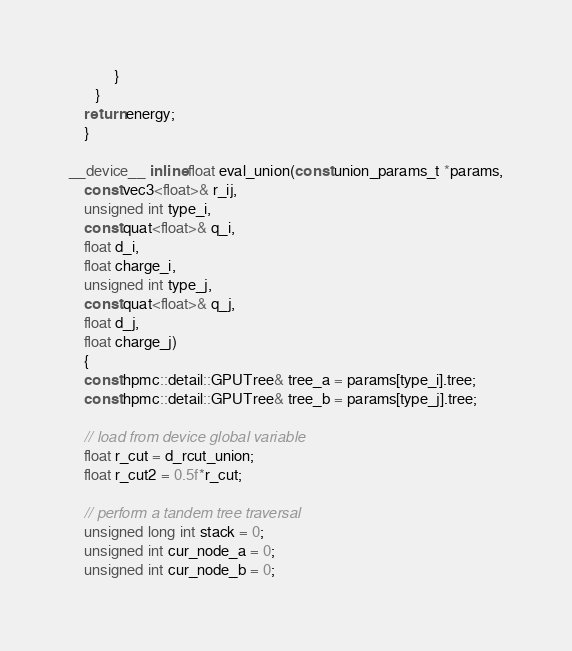Convert code to text. <code><loc_0><loc_0><loc_500><loc_500><_Cuda_>            }
       }
    return energy;
    }

__device__ inline float eval_union(const union_params_t *params,
    const vec3<float>& r_ij,
    unsigned int type_i,
    const quat<float>& q_i,
    float d_i,
    float charge_i,
    unsigned int type_j,
    const quat<float>& q_j,
    float d_j,
    float charge_j)
    {
    const hpmc::detail::GPUTree& tree_a = params[type_i].tree;
    const hpmc::detail::GPUTree& tree_b = params[type_j].tree;

    // load from device global variable
    float r_cut = d_rcut_union;
    float r_cut2 = 0.5f*r_cut;

    // perform a tandem tree traversal
    unsigned long int stack = 0;
    unsigned int cur_node_a = 0;
    unsigned int cur_node_b = 0;
</code> 